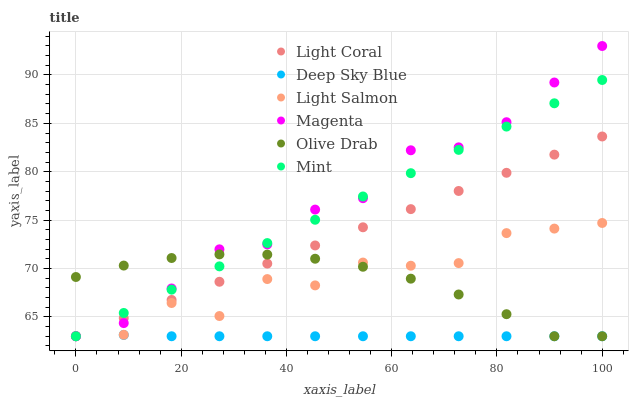Does Deep Sky Blue have the minimum area under the curve?
Answer yes or no. Yes. Does Magenta have the maximum area under the curve?
Answer yes or no. Yes. Does Light Coral have the minimum area under the curve?
Answer yes or no. No. Does Light Coral have the maximum area under the curve?
Answer yes or no. No. Is Light Coral the smoothest?
Answer yes or no. Yes. Is Light Salmon the roughest?
Answer yes or no. Yes. Is Deep Sky Blue the smoothest?
Answer yes or no. No. Is Deep Sky Blue the roughest?
Answer yes or no. No. Does Light Salmon have the lowest value?
Answer yes or no. Yes. Does Magenta have the highest value?
Answer yes or no. Yes. Does Light Coral have the highest value?
Answer yes or no. No. Does Light Coral intersect Mint?
Answer yes or no. Yes. Is Light Coral less than Mint?
Answer yes or no. No. Is Light Coral greater than Mint?
Answer yes or no. No. 